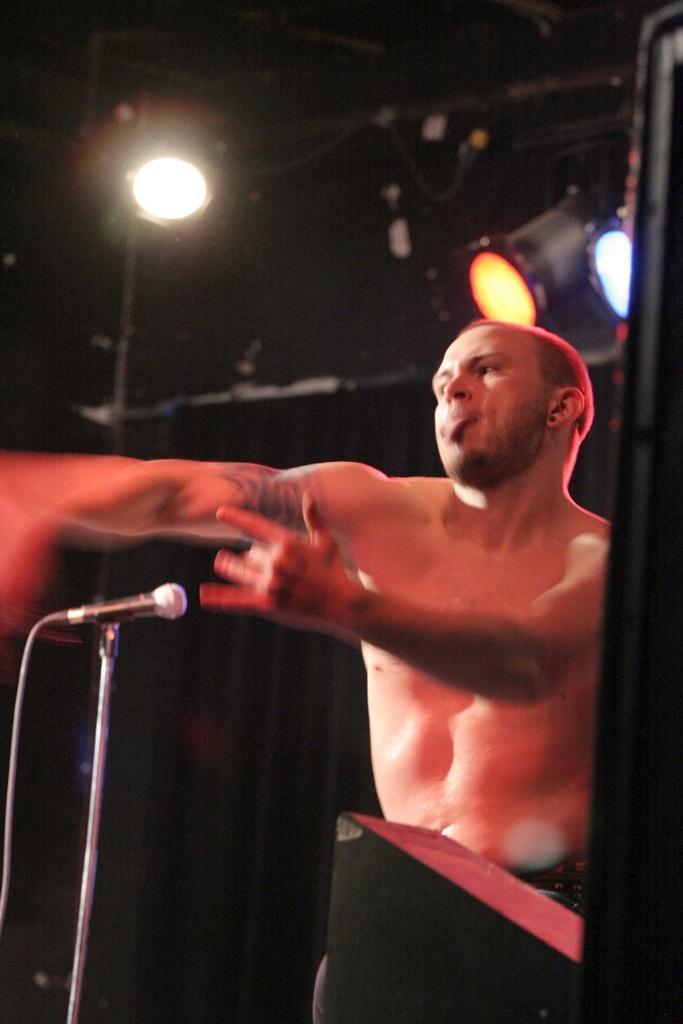Who is the main subject in the image? There is a man in the image. What object is in front of the man? There is a microphone on a stand in front of the man. What can be seen in the background of the image? There are lights visible in the background of the image. Where is the pig located in the image? There is no pig present in the image. What type of border is visible around the man in the image? There is no border visible around the man in the image. 